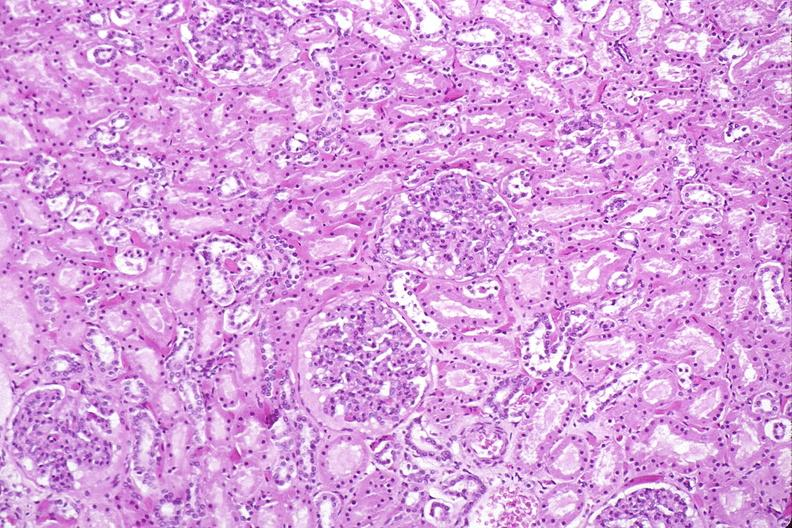what does this image show?
Answer the question using a single word or phrase. Kidney 